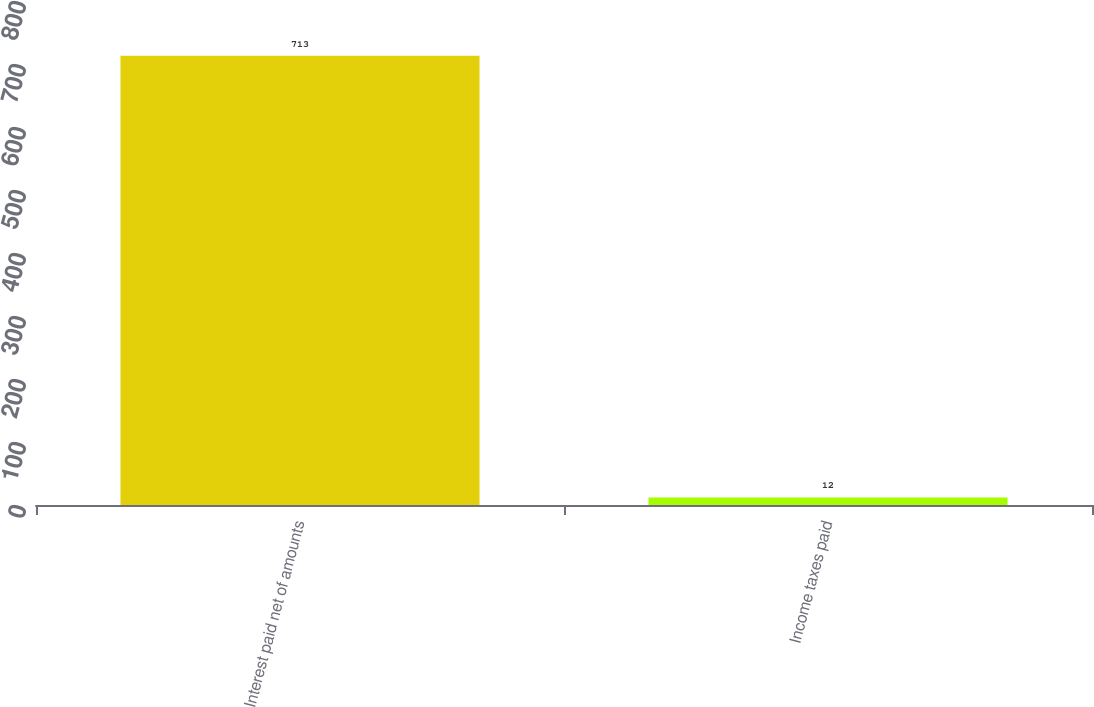Convert chart to OTSL. <chart><loc_0><loc_0><loc_500><loc_500><bar_chart><fcel>Interest paid net of amounts<fcel>Income taxes paid<nl><fcel>713<fcel>12<nl></chart> 